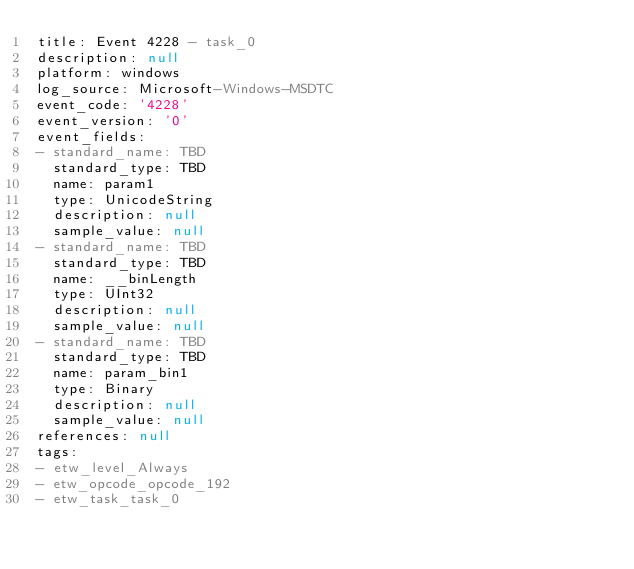<code> <loc_0><loc_0><loc_500><loc_500><_YAML_>title: Event 4228 - task_0
description: null
platform: windows
log_source: Microsoft-Windows-MSDTC
event_code: '4228'
event_version: '0'
event_fields:
- standard_name: TBD
  standard_type: TBD
  name: param1
  type: UnicodeString
  description: null
  sample_value: null
- standard_name: TBD
  standard_type: TBD
  name: __binLength
  type: UInt32
  description: null
  sample_value: null
- standard_name: TBD
  standard_type: TBD
  name: param_bin1
  type: Binary
  description: null
  sample_value: null
references: null
tags:
- etw_level_Always
- etw_opcode_opcode_192
- etw_task_task_0
</code> 